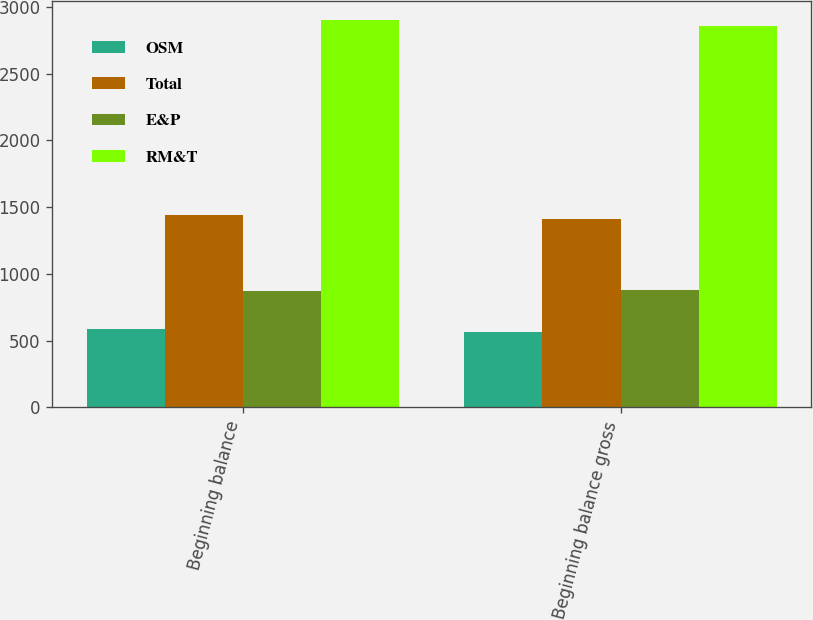<chart> <loc_0><loc_0><loc_500><loc_500><stacked_bar_chart><ecel><fcel>Beginning balance<fcel>Beginning balance gross<nl><fcel>OSM<fcel>590<fcel>568<nl><fcel>Total<fcel>1437<fcel>1412<nl><fcel>E&P<fcel>872<fcel>879<nl><fcel>RM&T<fcel>2899<fcel>2859<nl></chart> 